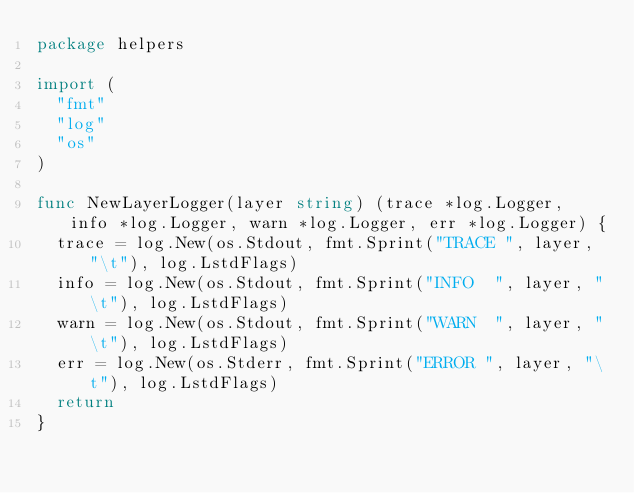Convert code to text. <code><loc_0><loc_0><loc_500><loc_500><_Go_>package helpers

import (
	"fmt"
	"log"
	"os"
)

func NewLayerLogger(layer string) (trace *log.Logger, info *log.Logger, warn *log.Logger, err *log.Logger) {
	trace = log.New(os.Stdout, fmt.Sprint("TRACE ", layer, "\t"), log.LstdFlags)
	info = log.New(os.Stdout, fmt.Sprint("INFO  ", layer, "\t"), log.LstdFlags)
	warn = log.New(os.Stdout, fmt.Sprint("WARN  ", layer, "\t"), log.LstdFlags)
	err = log.New(os.Stderr, fmt.Sprint("ERROR ", layer, "\t"), log.LstdFlags)
	return
}
</code> 